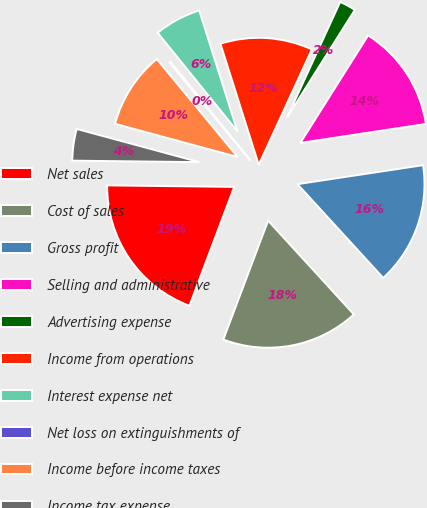Convert chart. <chart><loc_0><loc_0><loc_500><loc_500><pie_chart><fcel>Net sales<fcel>Cost of sales<fcel>Gross profit<fcel>Selling and administrative<fcel>Advertising expense<fcel>Income from operations<fcel>Interest expense net<fcel>Net loss on extinguishments of<fcel>Income before income taxes<fcel>Income tax expense<nl><fcel>19.46%<fcel>17.53%<fcel>15.6%<fcel>13.67%<fcel>2.09%<fcel>11.74%<fcel>5.95%<fcel>0.16%<fcel>9.81%<fcel>4.02%<nl></chart> 